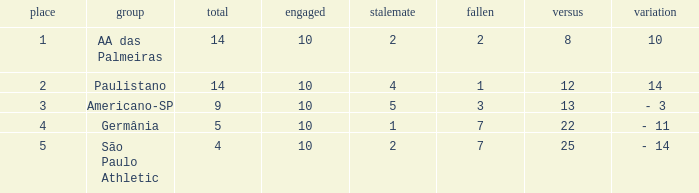Write the full table. {'header': ['place', 'group', 'total', 'engaged', 'stalemate', 'fallen', 'versus', 'variation'], 'rows': [['1', 'AA das Palmeiras', '14', '10', '2', '2', '8', '10'], ['2', 'Paulistano', '14', '10', '4', '1', '12', '14'], ['3', 'Americano-SP', '9', '10', '5', '3', '13', '- 3'], ['4', 'Germânia', '5', '10', '1', '7', '22', '- 11'], ['5', 'São Paulo Athletic', '4', '10', '2', '7', '25', '- 14']]} What is the lowest Against when the played is more than 10? None. 